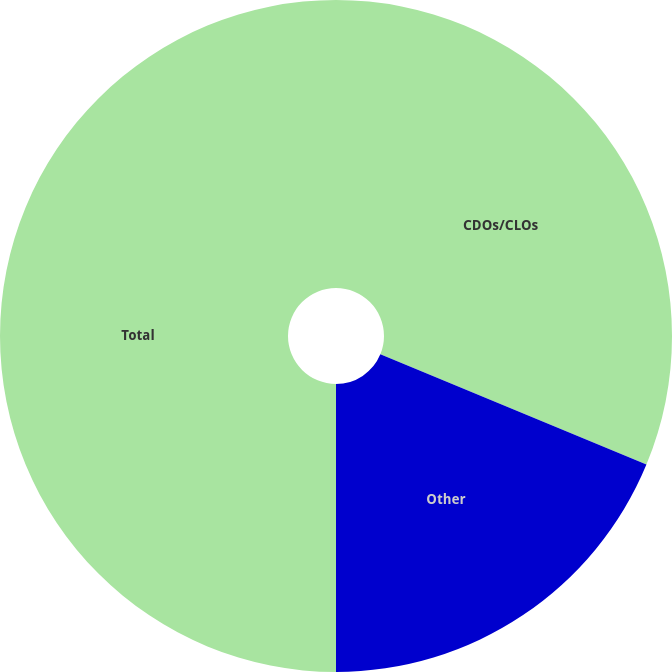Convert chart. <chart><loc_0><loc_0><loc_500><loc_500><pie_chart><fcel>CDOs/CLOs<fcel>Other<fcel>Total<nl><fcel>31.25%<fcel>18.75%<fcel>50.0%<nl></chart> 